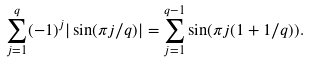<formula> <loc_0><loc_0><loc_500><loc_500>\sum _ { j = 1 } ^ { q } ( - 1 ) ^ { j } | \sin ( \pi j / q ) | & = \sum _ { j = 1 } ^ { q - 1 } \sin ( \pi j ( 1 + 1 / q ) ) .</formula> 